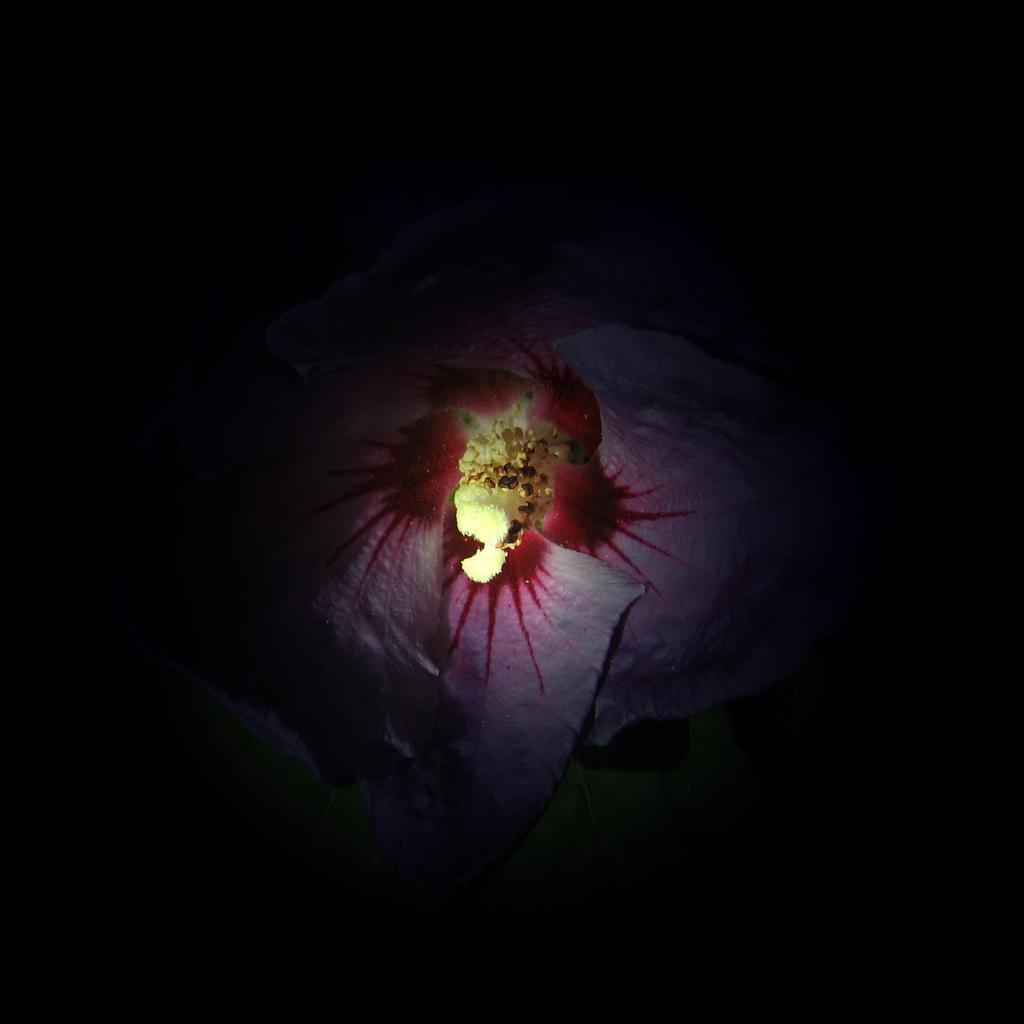Describe this image in one or two sentences. In this image I can see a cloth in red and white color and I can see dark background. 